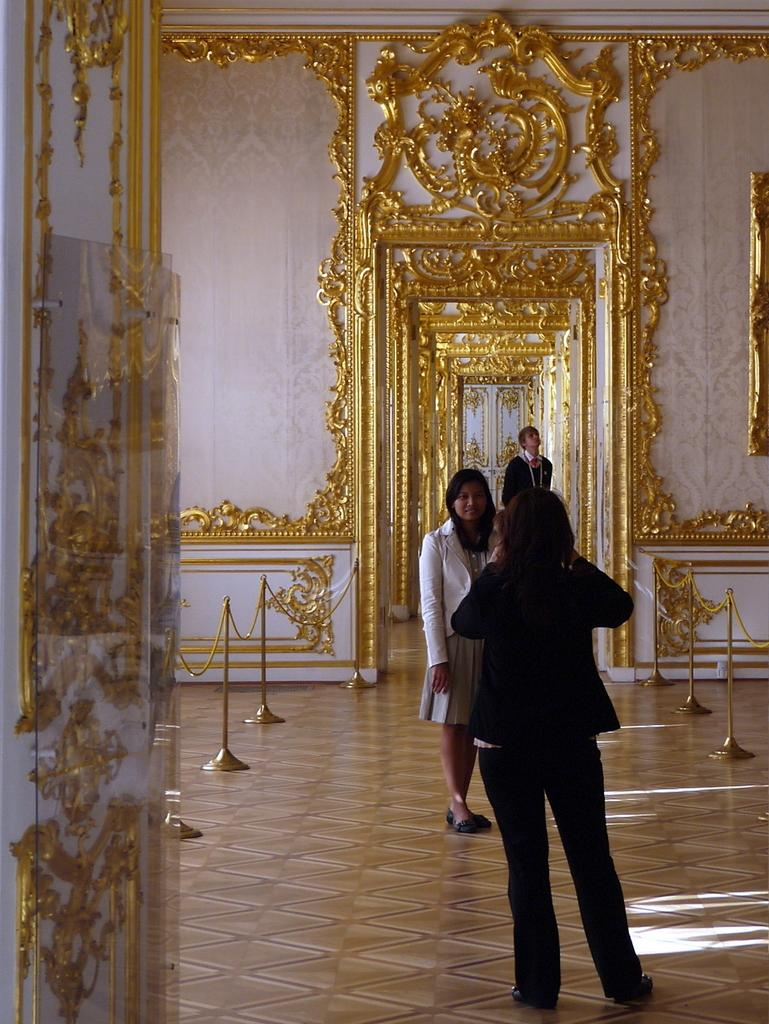What is happening in the image? There are people standing in the image. Can you describe the setting of the image? The image appears to be an indoor scene. What can be seen on the wall in the image? There are carvings on the wall. How would you describe the appearance of the wall? The wall has a designer appearance. What is the angle of the slope in the image? There is no slope present in the image; it is an indoor scene with people standing and a wall with carvings. 